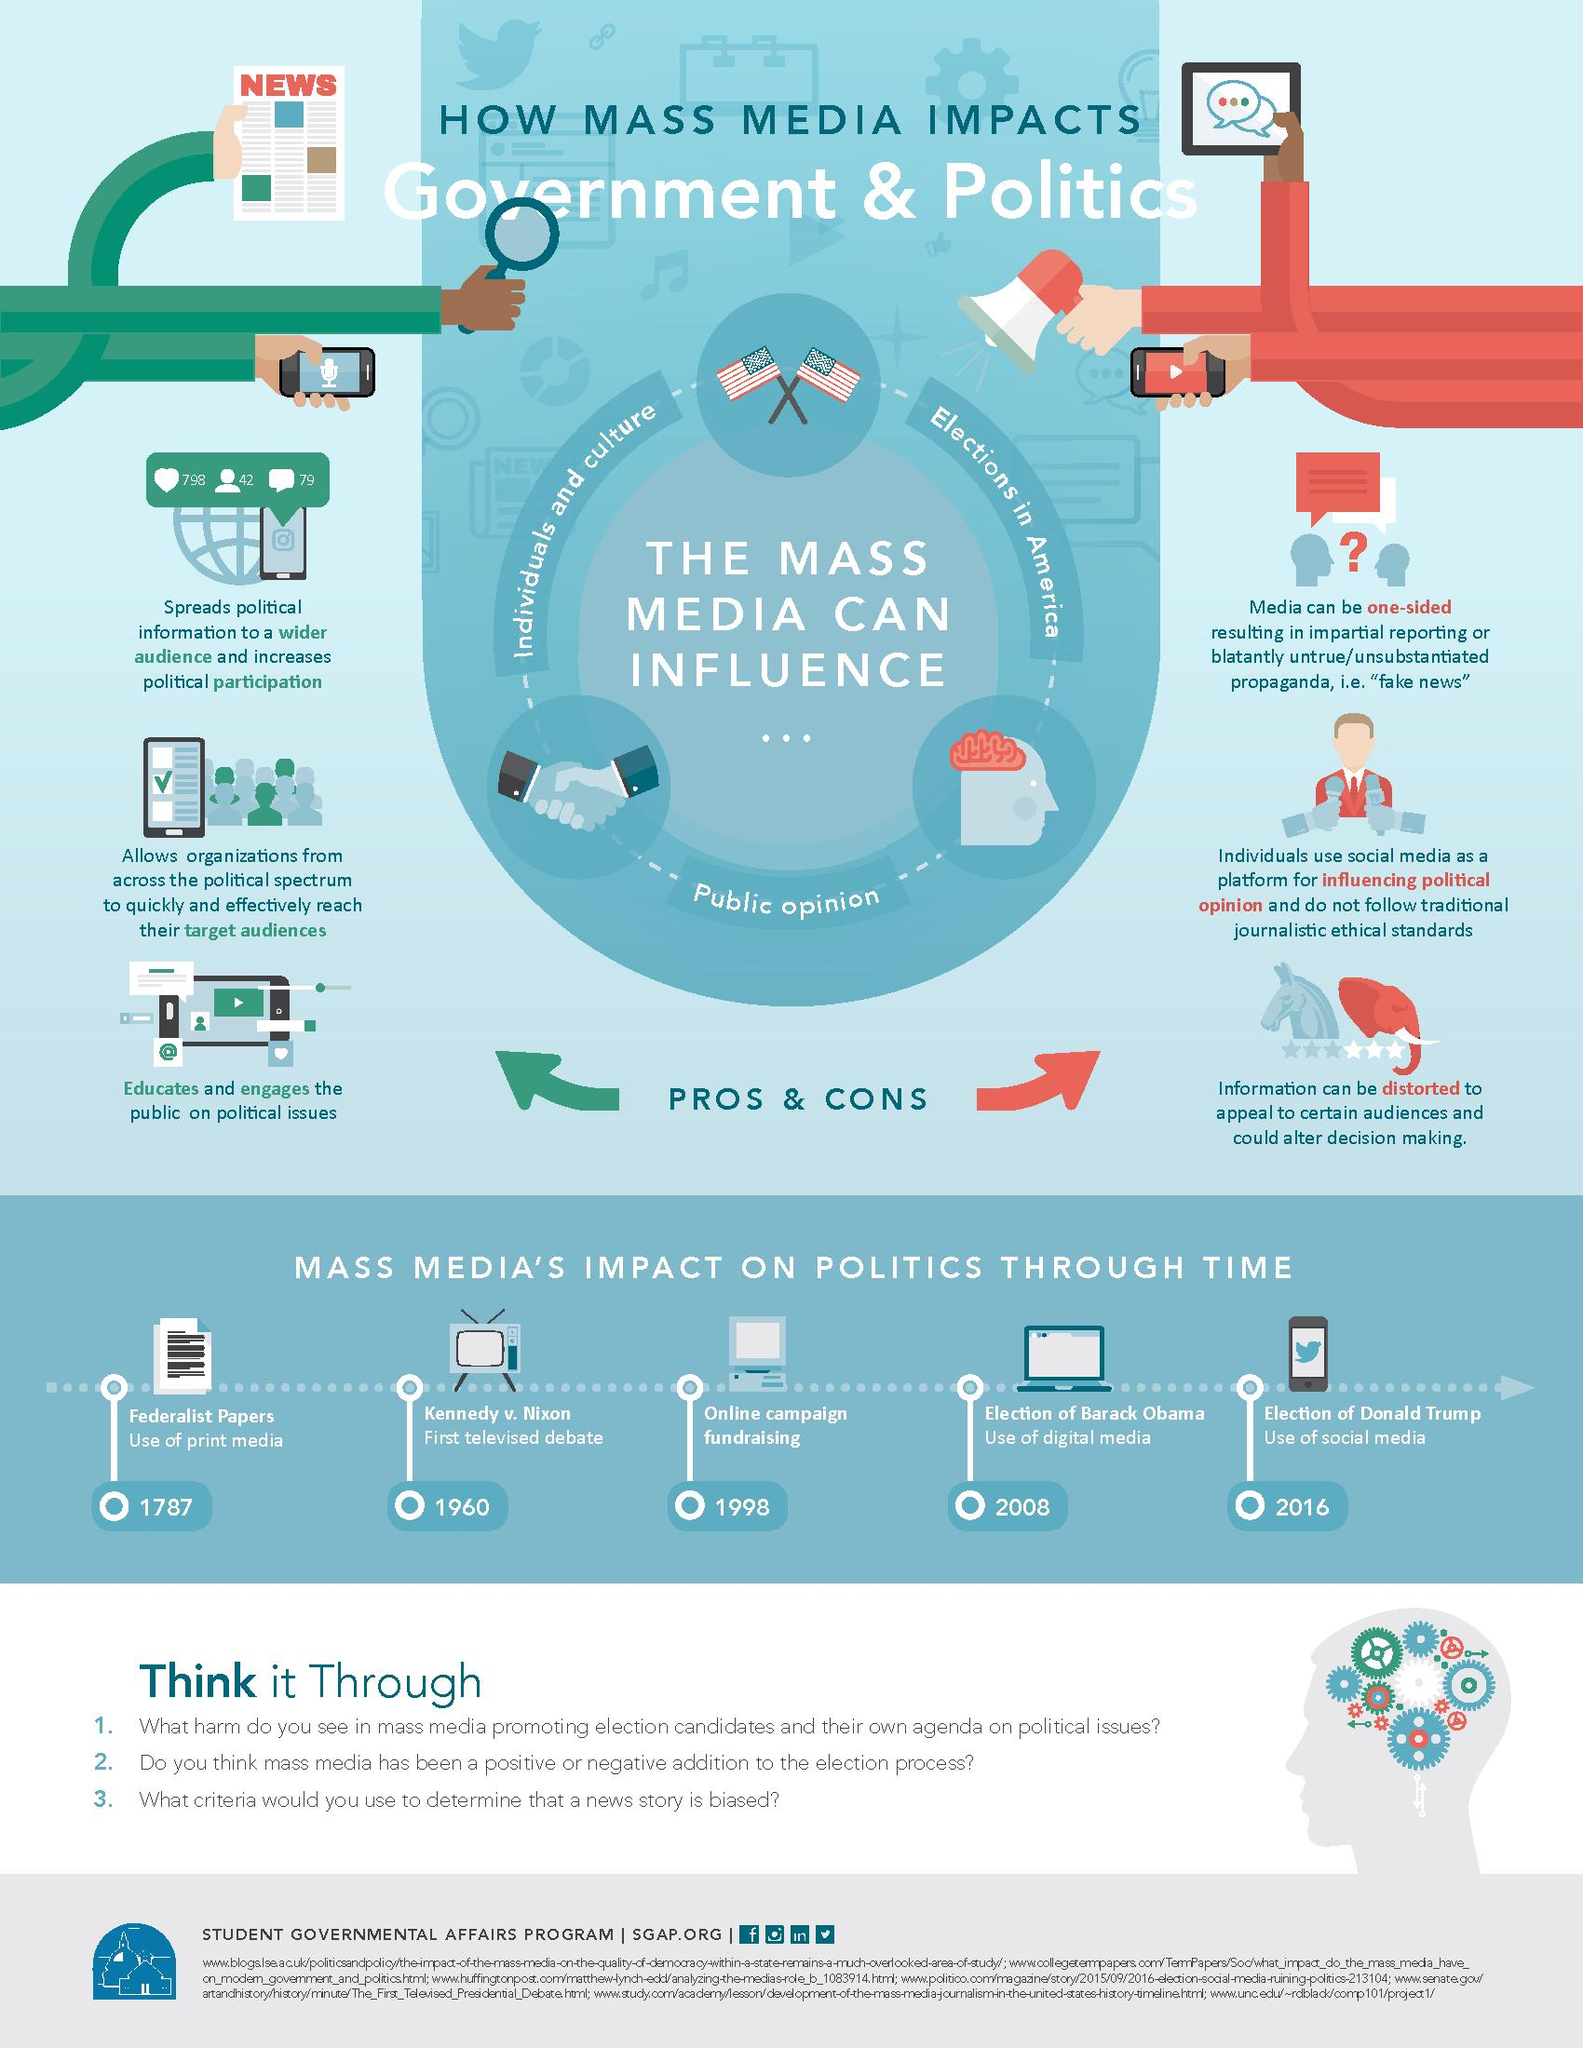Highlight a few significant elements in this photo. The first televised presidential debate in American history took place in 1960. The Federalist Papers began using print media in 1787. 